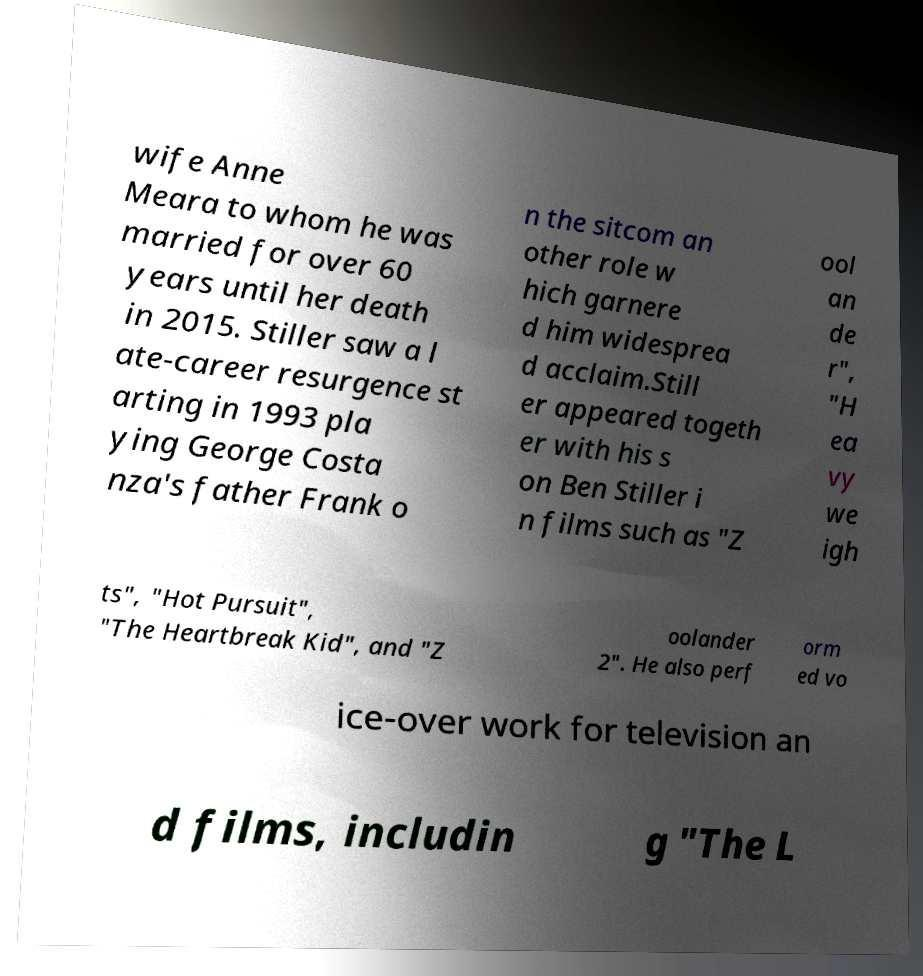Could you extract and type out the text from this image? wife Anne Meara to whom he was married for over 60 years until her death in 2015. Stiller saw a l ate-career resurgence st arting in 1993 pla ying George Costa nza's father Frank o n the sitcom an other role w hich garnere d him widesprea d acclaim.Still er appeared togeth er with his s on Ben Stiller i n films such as "Z ool an de r", "H ea vy we igh ts", "Hot Pursuit", "The Heartbreak Kid", and "Z oolander 2". He also perf orm ed vo ice-over work for television an d films, includin g "The L 